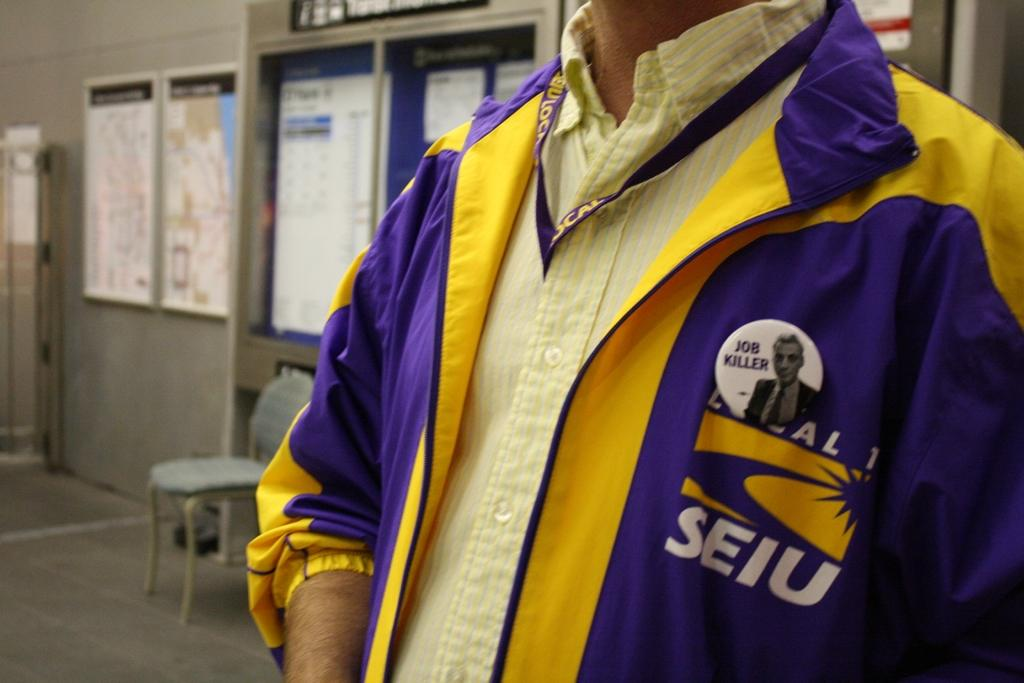<image>
Provide a brief description of the given image. A man is wearing purple and yellow clothes with a button on the jacket that says JOB KILLER on it. 